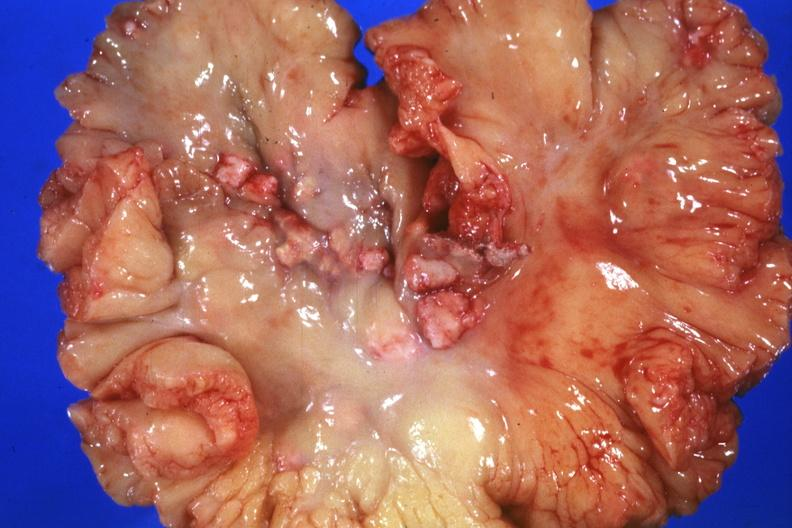s situs inversus present?
Answer the question using a single word or phrase. No 